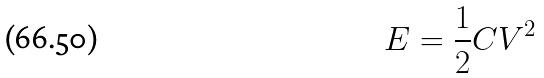Convert formula to latex. <formula><loc_0><loc_0><loc_500><loc_500>E = \frac { 1 } { 2 } C V ^ { 2 }</formula> 